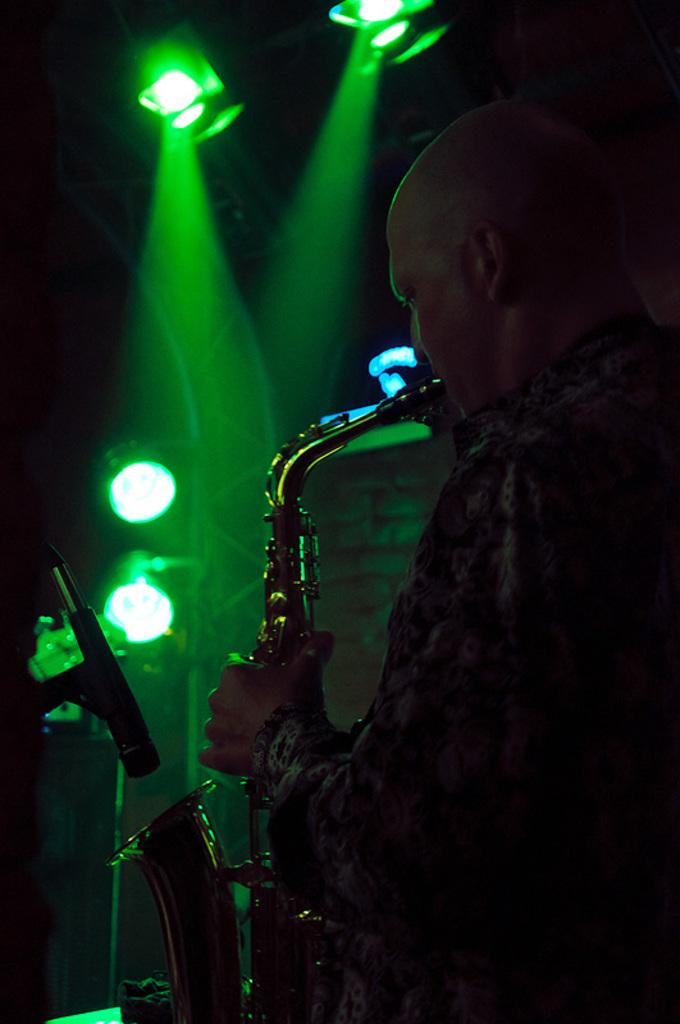What is the person in the image doing? The person in the image is playing the saxophone. What object is present that might be used for amplifying sound? There is a microphone (mike) in the image. What can be seen in the background of the image? There are lights visible in the background of the image. How many corks are visible in the image? There are no corks present in the image. What color are the person's eyes in the image? The person's eyes are not visible in the image, so their color cannot be determined. 